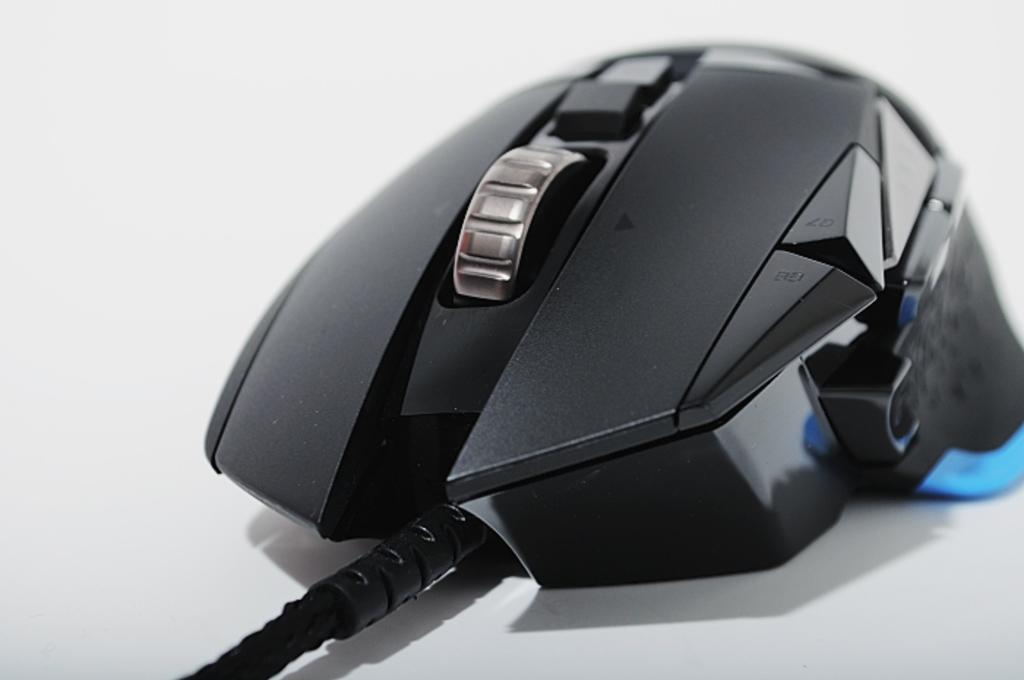What is the main subject of the image? There is a mouse in the image. How is the mouse connected to other devices? The mouse is connected to a cable. What is the color of the platform on which the mouse is placed? The mouse is on a white platform. What is the color of the background in the image? The background of the image is white. Can you see a chicken in the image? No, there is no chicken present in the image. What type of stick is the mouse holding in the image? There is no stick present in the image, and the mouse is not holding anything. 